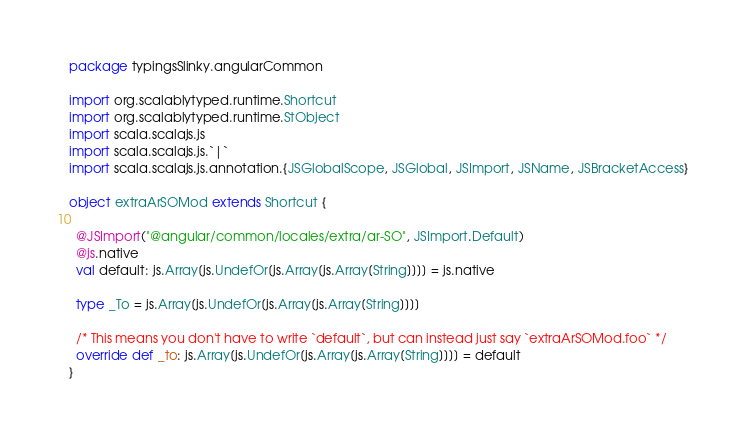Convert code to text. <code><loc_0><loc_0><loc_500><loc_500><_Scala_>package typingsSlinky.angularCommon

import org.scalablytyped.runtime.Shortcut
import org.scalablytyped.runtime.StObject
import scala.scalajs.js
import scala.scalajs.js.`|`
import scala.scalajs.js.annotation.{JSGlobalScope, JSGlobal, JSImport, JSName, JSBracketAccess}

object extraArSOMod extends Shortcut {
  
  @JSImport("@angular/common/locales/extra/ar-SO", JSImport.Default)
  @js.native
  val default: js.Array[js.UndefOr[js.Array[js.Array[String]]]] = js.native
  
  type _To = js.Array[js.UndefOr[js.Array[js.Array[String]]]]
  
  /* This means you don't have to write `default`, but can instead just say `extraArSOMod.foo` */
  override def _to: js.Array[js.UndefOr[js.Array[js.Array[String]]]] = default
}
</code> 